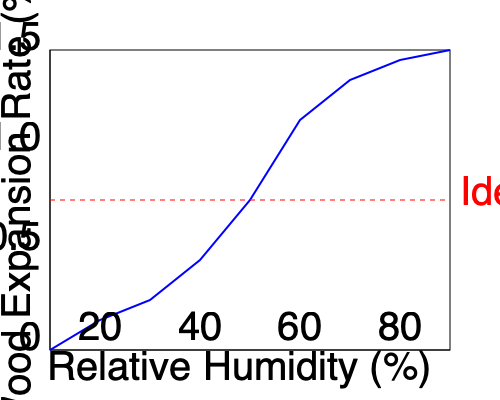Based on the graph showing wood expansion rates at different humidity levels, what is the ideal relative humidity range for piano storage to minimize wood expansion and potential damage to the instrument? To determine the ideal relative humidity range for piano storage, we need to analyze the graph and understand the relationship between humidity and wood expansion:

1. The x-axis represents relative humidity (%), while the y-axis shows wood expansion rate (%).

2. The curve demonstrates that wood expansion increases as relative humidity increases, but not in a linear fashion.

3. At lower humidity levels (0-20%), the expansion rate is minimal, but the wood may become too dry, leading to cracking or warping.

4. At higher humidity levels (80-100%), the expansion rate is very high, which can cause swelling, sticking keys, and other issues.

5. The red dashed line on the graph indicates an "Ideal Range" where wood expansion is moderate and controllable.

6. This ideal range corresponds to a relative humidity of approximately 40-60%.

7. Within this range, wood expansion is limited, and the piano's wooden components are less likely to suffer from extreme dryness or excessive moisture.

8. This humidity range allows for slight, natural expansion and contraction of wood without risking significant damage to the instrument.

9. Maintaining this 40-60% relative humidity range helps preserve the piano's tuning stability, action regulation, and overall structural integrity.

Therefore, based on the graph and considering the balance between preventing both dryness and excessive moisture, the ideal relative humidity range for piano storage is 40-60%.
Answer: 40-60% relative humidity 